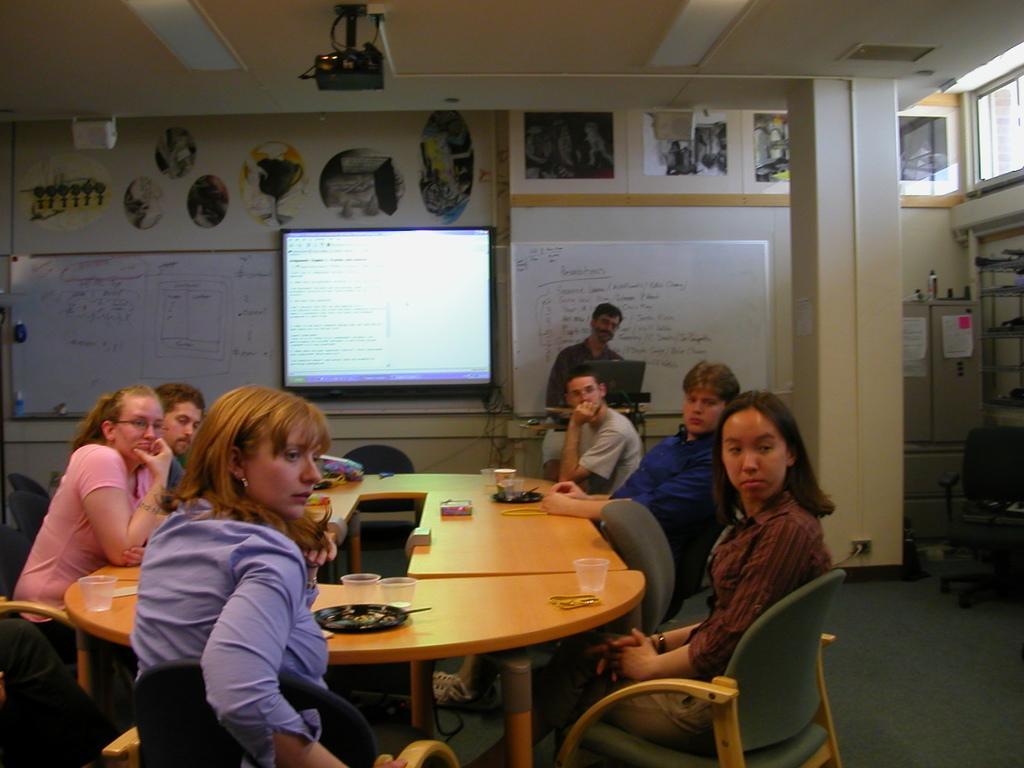Could you give a brief overview of what you see in this image? In this image few people are sitting on the chair there are few glass,plates on the table. At the back ground there is a screen, board,papers attached to a wall,at the top there is a projector. 